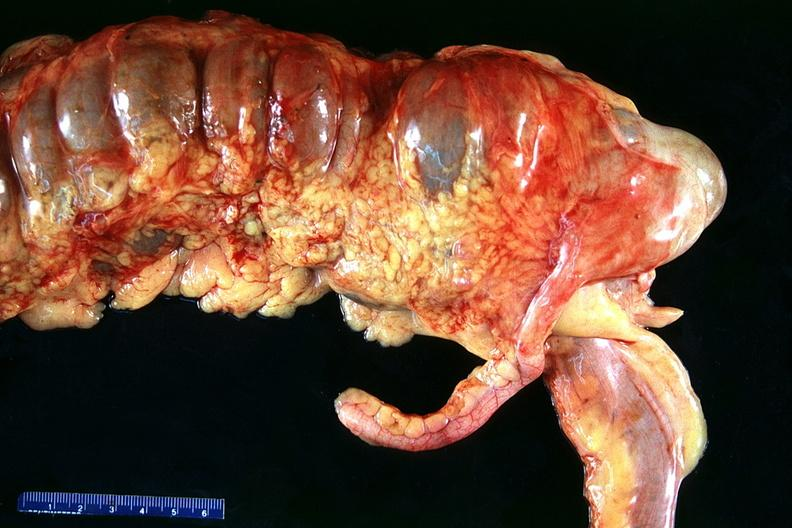s gastrointestinal present?
Answer the question using a single word or phrase. Yes 